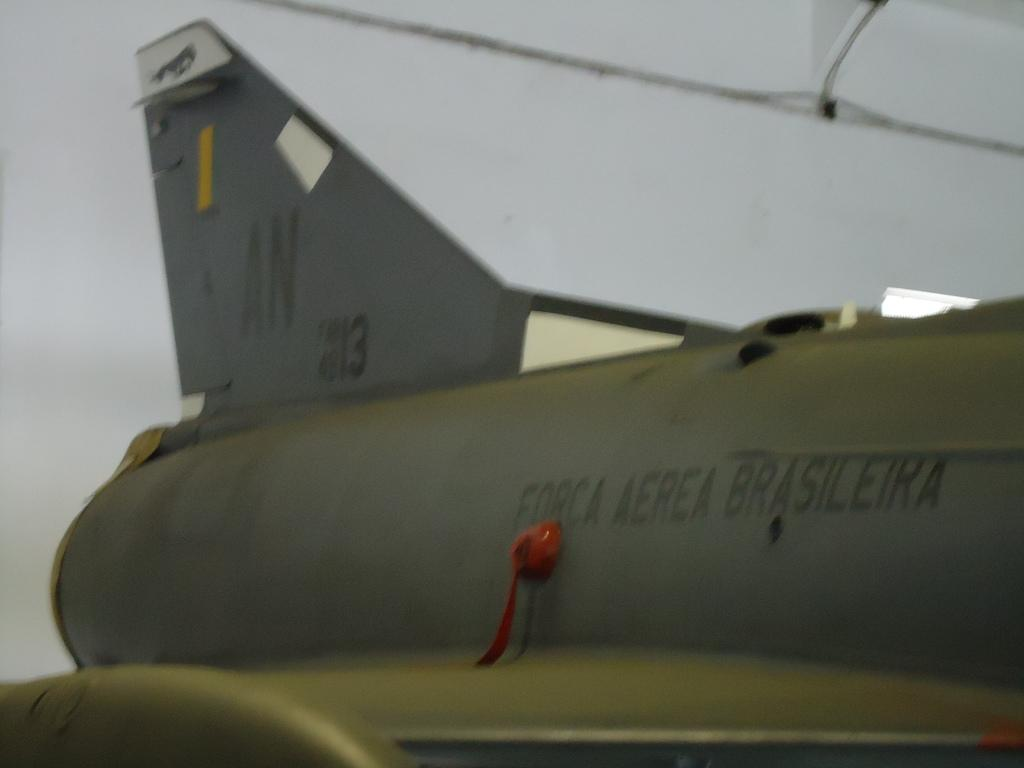<image>
Write a terse but informative summary of the picture. The plane from the Brazilian airforce is numbered 13. 